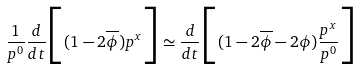<formula> <loc_0><loc_0><loc_500><loc_500>\frac { 1 } { p ^ { 0 } } \frac { d } { d t } \Big { [ } ( 1 - 2 \overline { \phi } ) p ^ { x } \Big { ] } \simeq \frac { d } { d t } \Big { [ } ( 1 - 2 \overline { \phi } - 2 \phi ) \frac { p ^ { x } } { p ^ { 0 } } \Big { ] }</formula> 